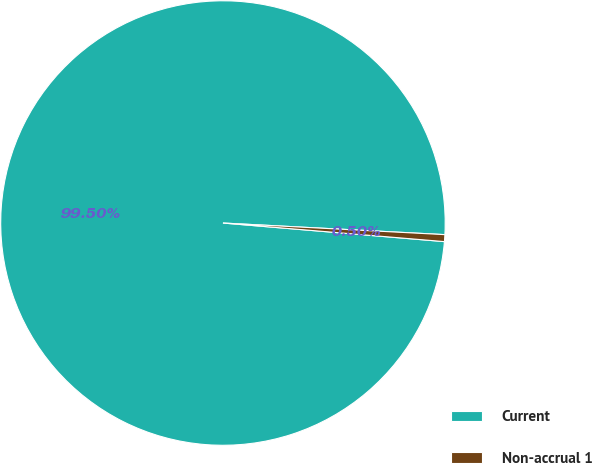<chart> <loc_0><loc_0><loc_500><loc_500><pie_chart><fcel>Current<fcel>Non-accrual 1<nl><fcel>99.5%<fcel>0.5%<nl></chart> 